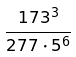Convert formula to latex. <formula><loc_0><loc_0><loc_500><loc_500>\frac { 1 7 3 ^ { 3 } } { 2 7 7 \cdot 5 ^ { 6 } }</formula> 